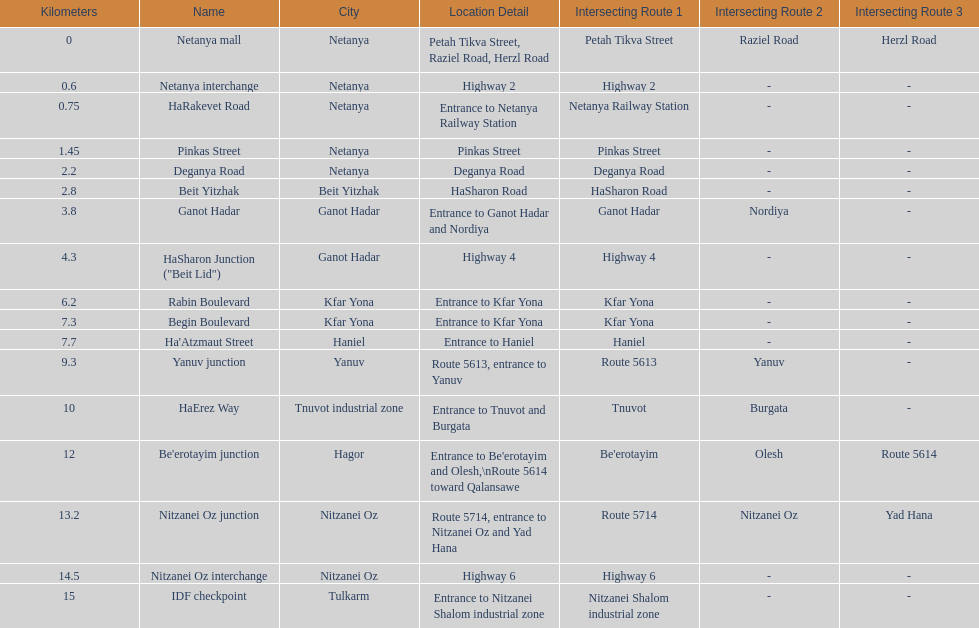Which location comes after kfar yona? Haniel. 